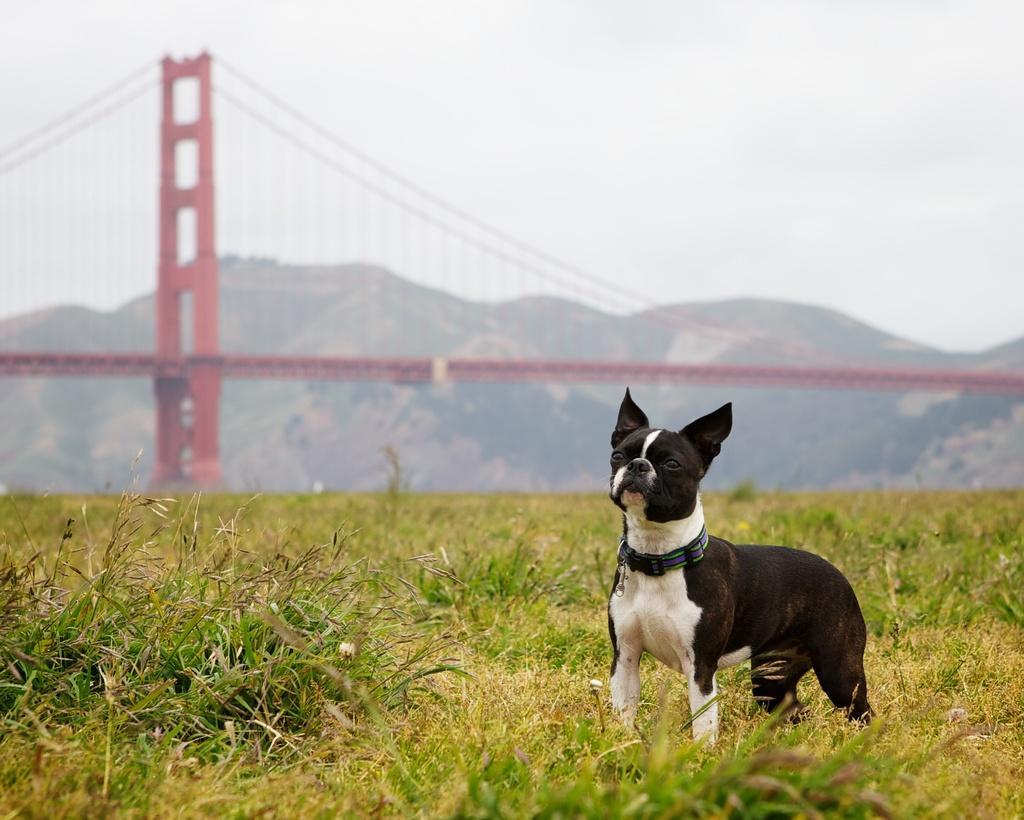Can you describe this image briefly? In the image there is a dog standing in between the grass on a surface, behind the dog there is a bridge and behind the bridge there are some mountains. 